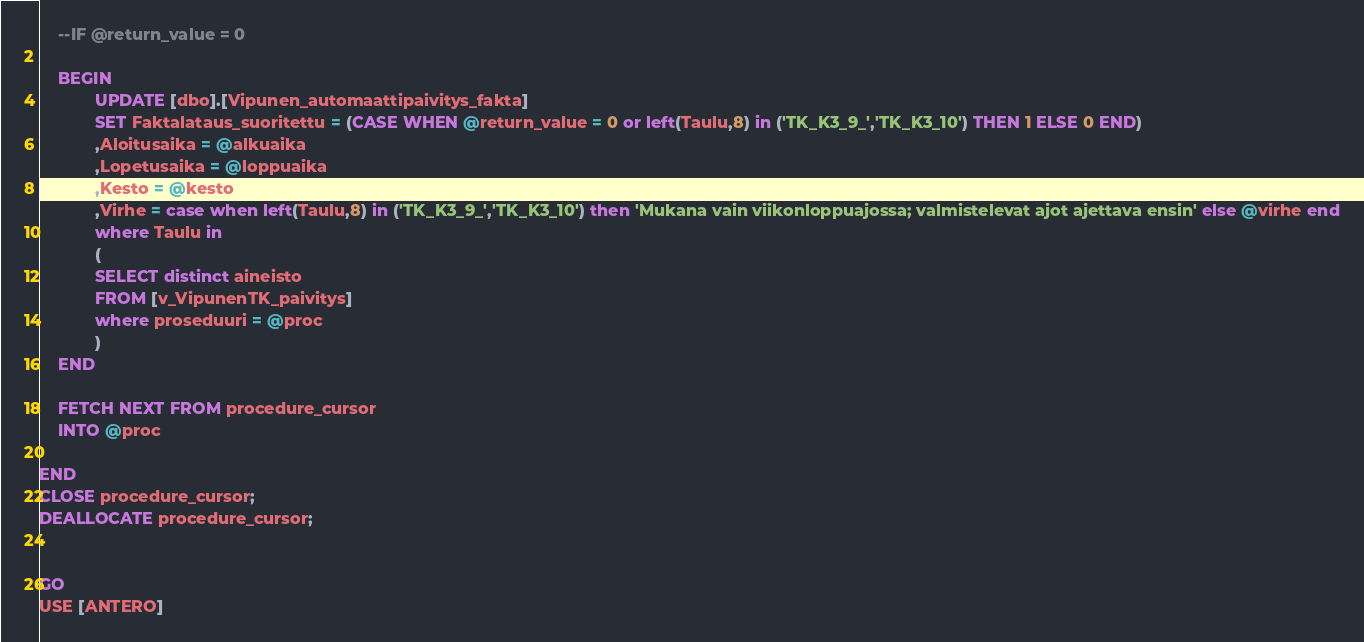<code> <loc_0><loc_0><loc_500><loc_500><_SQL_>	--IF @return_value = 0 
	
	BEGIN
			UPDATE [dbo].[Vipunen_automaattipaivitys_fakta] 
			SET Faktalataus_suoritettu = (CASE WHEN @return_value = 0 or left(Taulu,8) in ('TK_K3_9_','TK_K3_10') THEN 1 ELSE 0 END)
			,Aloitusaika = @alkuaika
			,Lopetusaika = @loppuaika
			,Kesto = @kesto
			,Virhe = case when left(Taulu,8) in ('TK_K3_9_','TK_K3_10') then 'Mukana vain viikonloppuajossa; valmistelevat ajot ajettava ensin' else @virhe end
			where Taulu in
			(
			SELECT distinct aineisto
			FROM [v_VipunenTK_paivitys]
			where proseduuri = @proc
			)
	END	

    FETCH NEXT FROM procedure_cursor 
	INTO @proc

END 
CLOSE procedure_cursor;
DEALLOCATE procedure_cursor;


GO
USE [ANTERO]</code> 